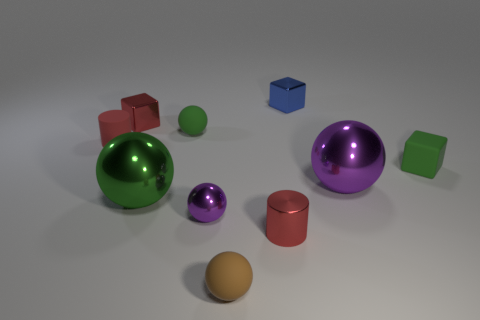Is the color of the small shiny cylinder the same as the matte cylinder?
Your response must be concise. Yes. What number of things are blocks or tiny purple objects?
Keep it short and to the point. 4. There is a metallic thing that is both to the left of the small purple thing and on the right side of the red block; what is its size?
Offer a very short reply. Large. What number of other cubes have the same material as the small blue cube?
Ensure brevity in your answer.  1. There is a cylinder that is made of the same material as the small blue block; what color is it?
Your answer should be compact. Red. Do the small cylinder behind the large purple metal ball and the small shiny cylinder have the same color?
Your answer should be compact. Yes. What is the material of the tiny red cylinder that is in front of the small purple shiny ball?
Offer a very short reply. Metal. Are there the same number of purple objects that are behind the small purple ball and big red rubber cylinders?
Offer a very short reply. No. How many small objects have the same color as the rubber cube?
Ensure brevity in your answer.  1. The other tiny thing that is the same shape as the red rubber object is what color?
Ensure brevity in your answer.  Red. 